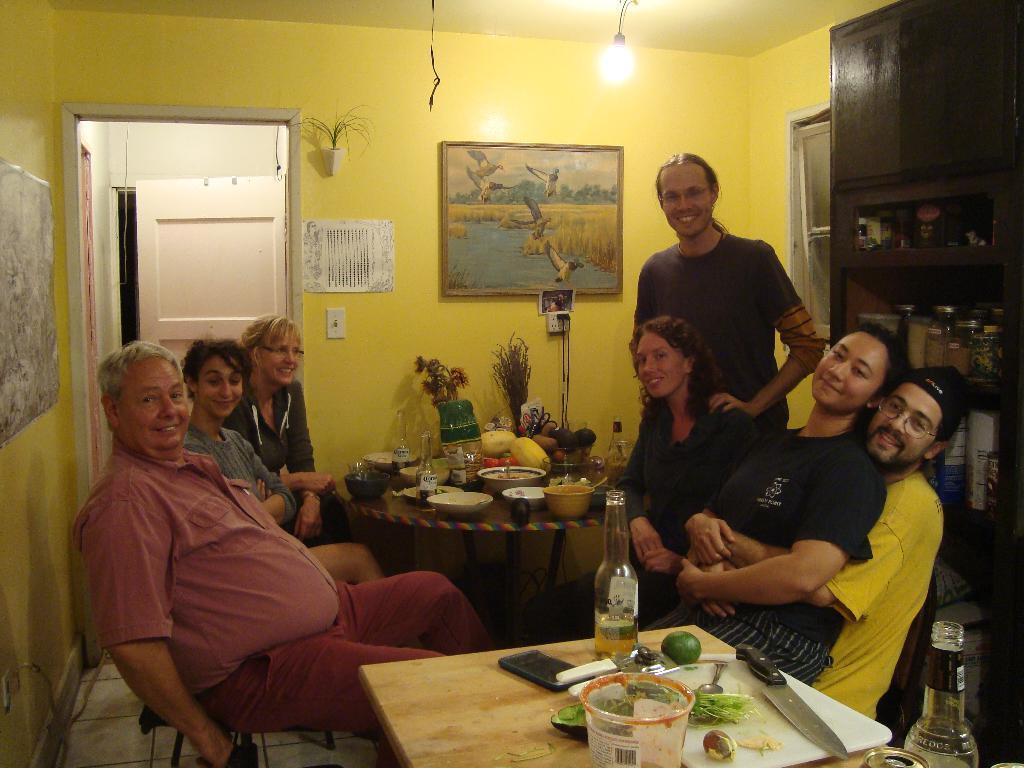Can you describe this image briefly? In this picture we can see some persons are sitting on the chairs. This is table. On the table there is a bottle, knife, bowls, and glasses. On the background there is a wall and this is frame. Here we can see a door and this is light. 